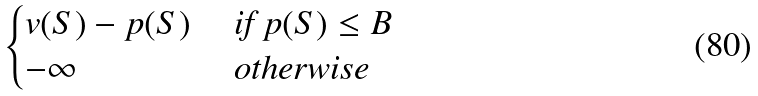Convert formula to latex. <formula><loc_0><loc_0><loc_500><loc_500>\begin{cases} v ( S ) - p ( S ) & \text { if $p(S) \leq B$} \\ - \infty & \text { otherwise} \\ \end{cases}</formula> 